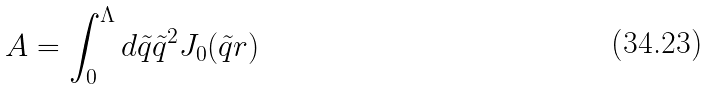<formula> <loc_0><loc_0><loc_500><loc_500>A = \int _ { 0 } ^ { \Lambda } d \tilde { q } \tilde { q } ^ { 2 } J _ { 0 } ( \tilde { q } r )</formula> 